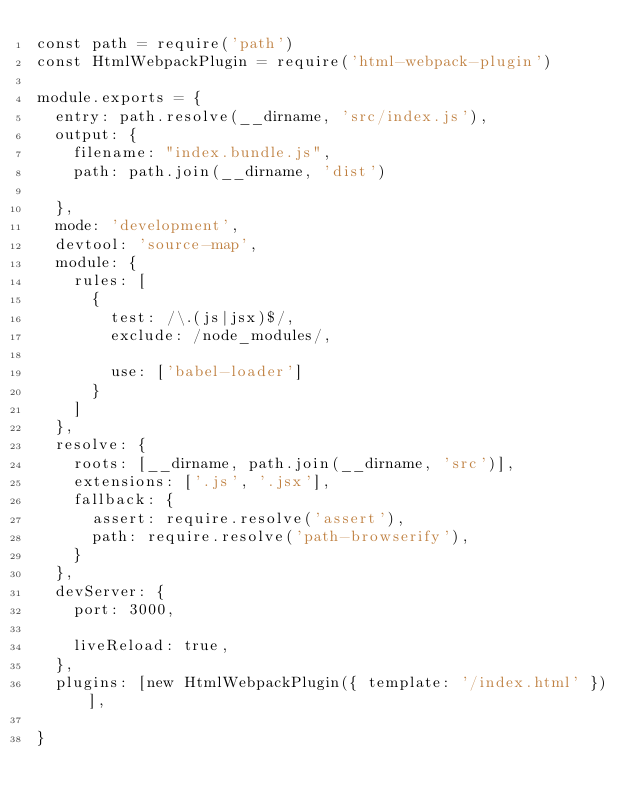Convert code to text. <code><loc_0><loc_0><loc_500><loc_500><_JavaScript_>const path = require('path')
const HtmlWebpackPlugin = require('html-webpack-plugin')

module.exports = {
  entry: path.resolve(__dirname, 'src/index.js'),
  output: {
    filename: "index.bundle.js",
    path: path.join(__dirname, 'dist')

  },
  mode: 'development',
  devtool: 'source-map',
  module: {
    rules: [
      {
        test: /\.(js|jsx)$/,
        exclude: /node_modules/,

        use: ['babel-loader']
      }
    ]
  },
  resolve: {
    roots: [__dirname, path.join(__dirname, 'src')],
    extensions: ['.js', '.jsx'],
    fallback: {
      assert: require.resolve('assert'),
      path: require.resolve('path-browserify'),
    }
  },
  devServer: {
    port: 3000,

    liveReload: true,
  },
  plugins: [new HtmlWebpackPlugin({ template: '/index.html' })],

}</code> 